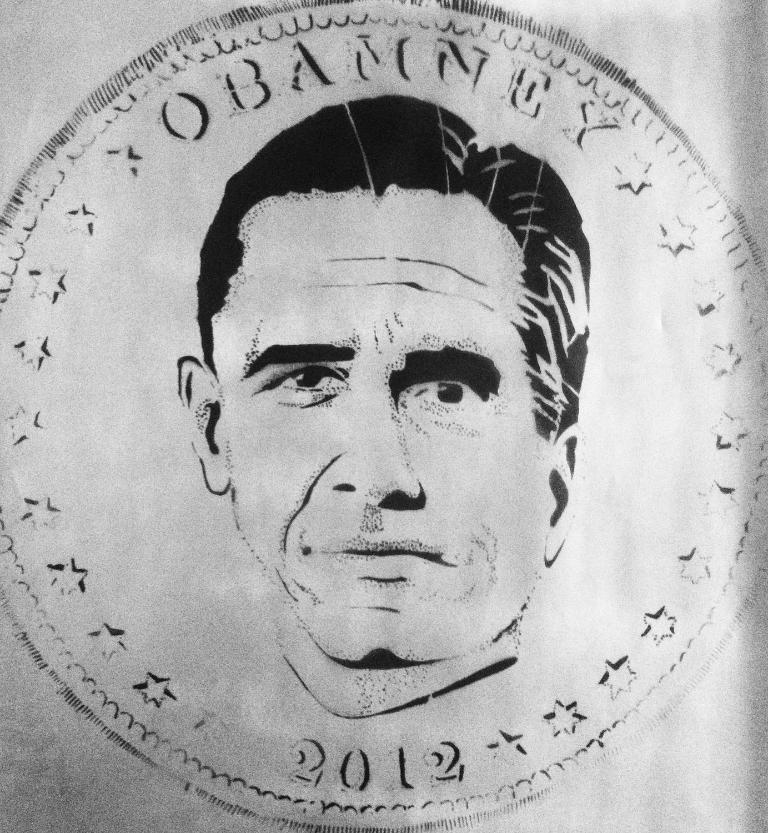What is the color scheme of the image? The image is black and white. What is depicted in the image? There is a sketch of a coin in the image. What can be seen on the coin? The coin has a person's face on it. How many horses are running in the image? There are no horses present in the image; it features a sketch of a coin with a person's face on it. What is the smell of the person's nose on the coin? The image is in black and white, so it is not possible to determine the smell of the person's nose on the coin. 